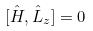Convert formula to latex. <formula><loc_0><loc_0><loc_500><loc_500>[ \hat { H } , \hat { L } _ { z } ] = 0</formula> 